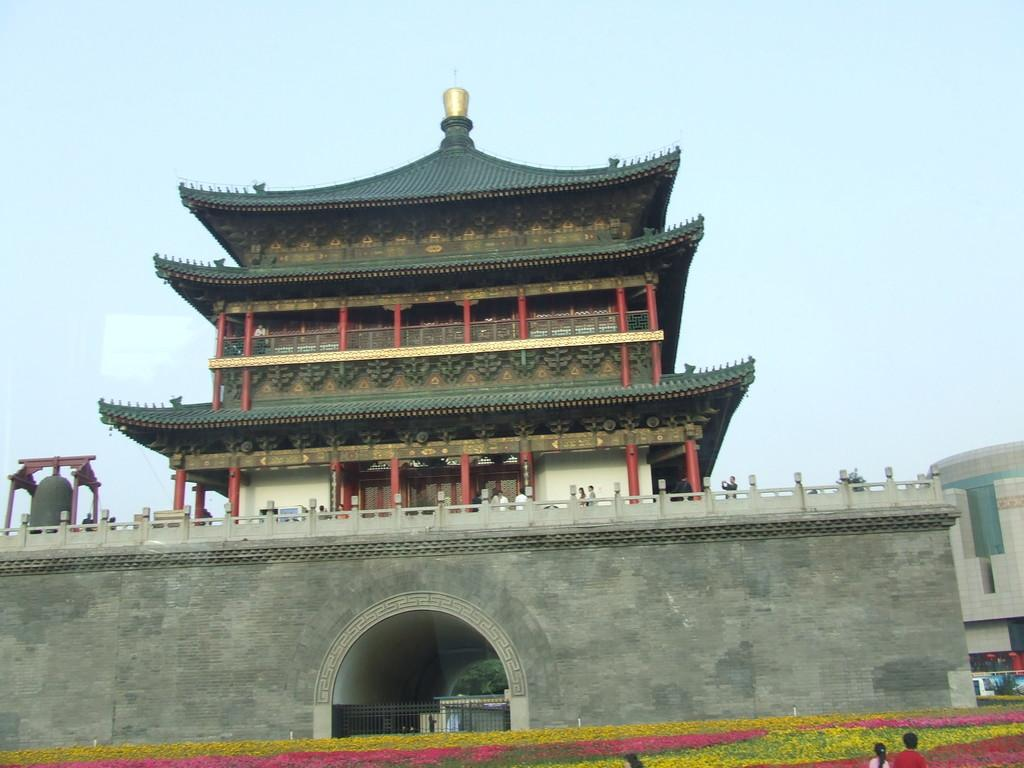What type of structures can be seen in the image? There are buildings in the image. What kind of vegetation is present in the image? There are plants with flowers in the image. Can you describe the people in the image? There are people standing in the image. How would you describe the weather in the image? The sky is cloudy in the image. What type of natural element is visible in the image? There is a tree in the image. How many ants are crawling on the tree in the image? There are no ants visible in the image; it only shows a tree. What achievements have the people in the image accomplished? The image does not provide information about the people's achievements, so it cannot be determined from the image. 